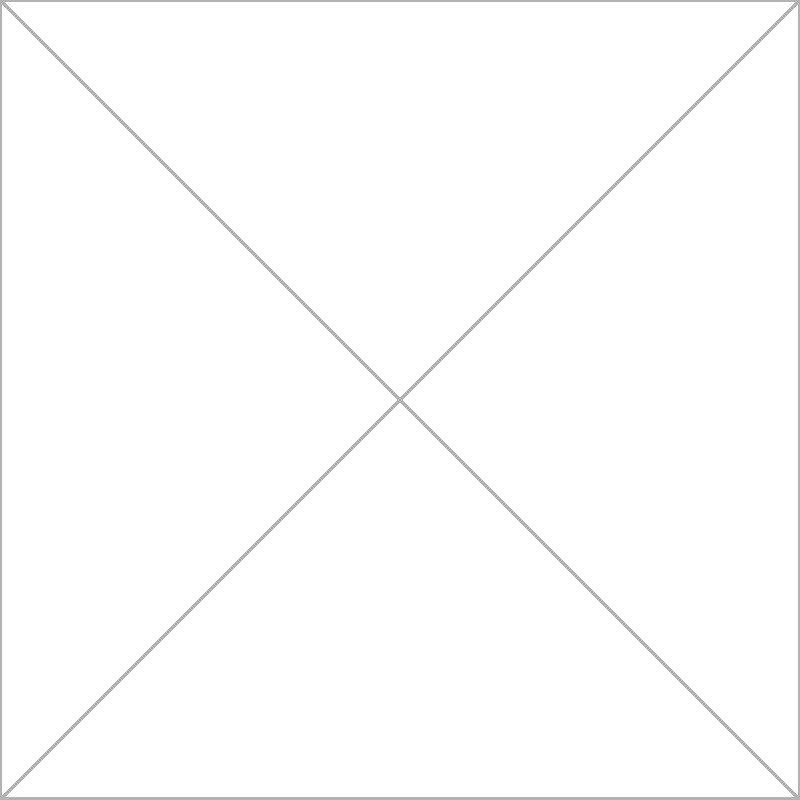In the network diagram representing interdisciplinary connections in liberal arts education, which discipline has the highest degree centrality, and how does this reflect the integrative nature of liberal arts studies? To answer this question, we need to follow these steps:

1. Understand degree centrality:
   Degree centrality is the number of direct connections a node has in a network.

2. Count connections for each discipline:
   - Philosophy: 4 connections
   - Literature: 4 connections
   - History: 4 connections
   - Sociology: 4 connections
   - Psychology: 4 connections

3. Identify the highest degree centrality:
   All disciplines have the same degree centrality (4), which is the maximum possible in this network of 5 nodes.

4. Interpret the result:
   The equal and maximum degree centrality for all disciplines reflects the integrative nature of liberal arts education. It shows that:
   a) Each discipline is connected to all others, emphasizing interdisciplinary study.
   b) No single discipline is more central, supporting a balanced approach to learning.
   c) The network structure encourages students to draw connections across all fields.

5. Relate to liberal arts education:
   This network structure aligns with the liberal arts philosophy of providing a well-rounded education that encourages critical thinking and the ability to synthesize knowledge from various disciplines.
Answer: All disciplines have equal, maximum degree centrality, reflecting the integrative and balanced nature of liberal arts education. 